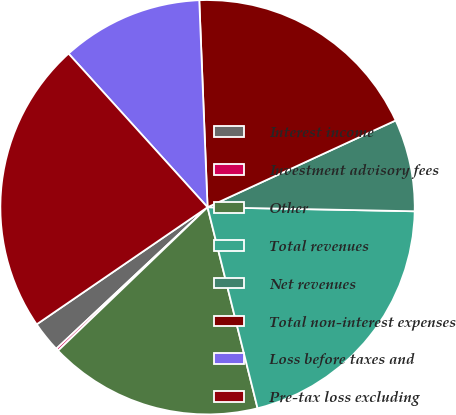Convert chart to OTSL. <chart><loc_0><loc_0><loc_500><loc_500><pie_chart><fcel>Interest income<fcel>Investment advisory fees<fcel>Other<fcel>Total revenues<fcel>Net revenues<fcel>Total non-interest expenses<fcel>Loss before taxes and<fcel>Pre-tax loss excluding<nl><fcel>2.41%<fcel>0.2%<fcel>16.71%<fcel>20.81%<fcel>7.19%<fcel>18.76%<fcel>11.07%<fcel>22.86%<nl></chart> 